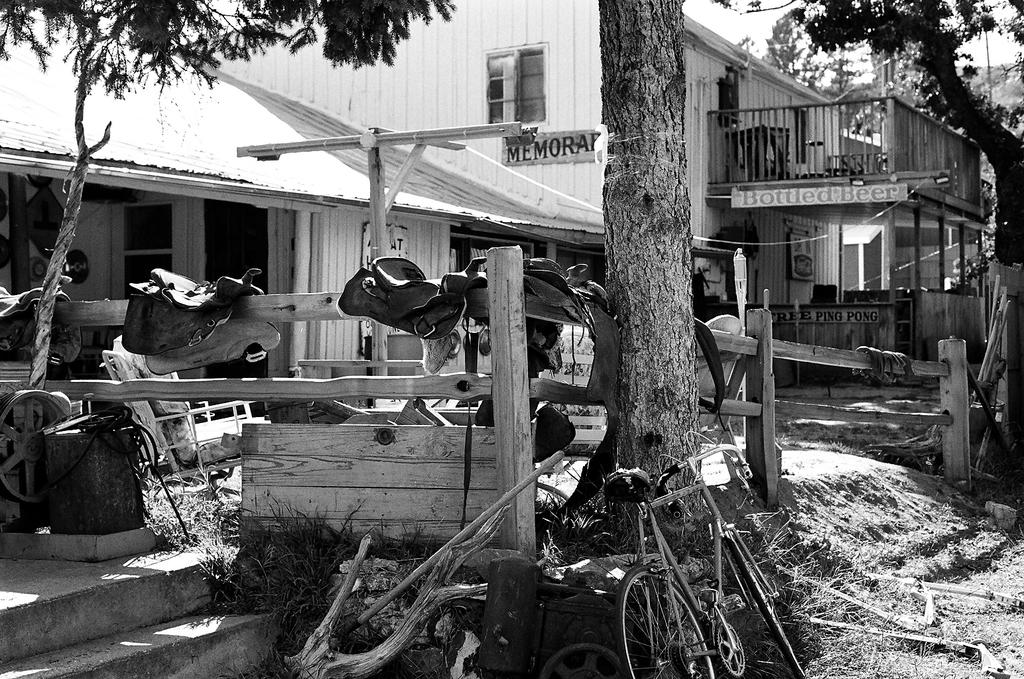What is the main object in the image? There is a bicycle in the image. What type of natural elements can be seen in the image? There are trees in the image. What type of objects are made of wood in the image? There are wooden objects in the image. What can be seen in the background of the image? The background of the image includes houses and the sky. What is the color scheme of the image? The image is in black and white. What type of story is being told by the toy in the image? There is no toy present in the image, so no story can be told by a toy. 